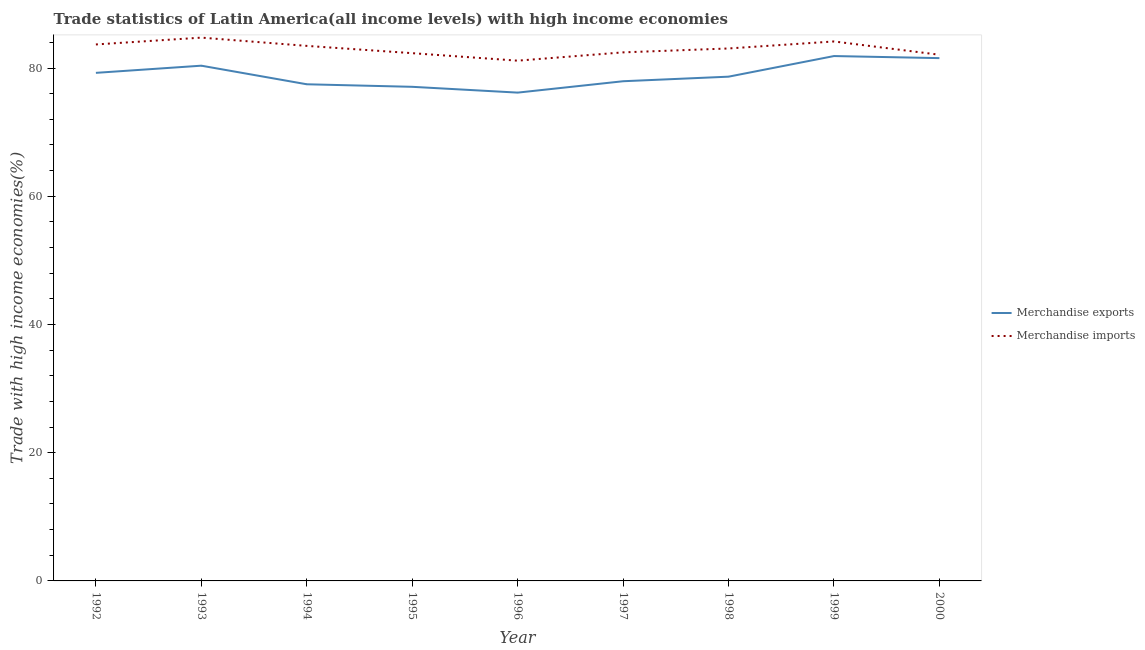Is the number of lines equal to the number of legend labels?
Ensure brevity in your answer.  Yes. What is the merchandise exports in 1997?
Give a very brief answer. 77.94. Across all years, what is the maximum merchandise imports?
Offer a terse response. 84.74. Across all years, what is the minimum merchandise imports?
Provide a short and direct response. 81.15. In which year was the merchandise exports minimum?
Ensure brevity in your answer.  1996. What is the total merchandise imports in the graph?
Provide a succinct answer. 747.07. What is the difference between the merchandise exports in 1992 and that in 2000?
Give a very brief answer. -2.3. What is the difference between the merchandise imports in 1997 and the merchandise exports in 2000?
Your response must be concise. 0.9. What is the average merchandise exports per year?
Your response must be concise. 78.93. In the year 1996, what is the difference between the merchandise imports and merchandise exports?
Your answer should be compact. 4.98. In how many years, is the merchandise imports greater than 28 %?
Provide a short and direct response. 9. What is the ratio of the merchandise exports in 1994 to that in 1998?
Offer a terse response. 0.98. What is the difference between the highest and the second highest merchandise imports?
Give a very brief answer. 0.6. What is the difference between the highest and the lowest merchandise exports?
Offer a terse response. 5.7. In how many years, is the merchandise exports greater than the average merchandise exports taken over all years?
Keep it short and to the point. 4. Is the sum of the merchandise imports in 1994 and 1995 greater than the maximum merchandise exports across all years?
Make the answer very short. Yes. Is the merchandise exports strictly greater than the merchandise imports over the years?
Your response must be concise. No. Is the merchandise imports strictly less than the merchandise exports over the years?
Offer a terse response. No. How many years are there in the graph?
Your answer should be compact. 9. What is the difference between two consecutive major ticks on the Y-axis?
Your answer should be compact. 20. Are the values on the major ticks of Y-axis written in scientific E-notation?
Provide a succinct answer. No. Does the graph contain any zero values?
Your answer should be compact. No. Where does the legend appear in the graph?
Provide a succinct answer. Center right. How many legend labels are there?
Provide a succinct answer. 2. How are the legend labels stacked?
Provide a succinct answer. Vertical. What is the title of the graph?
Provide a succinct answer. Trade statistics of Latin America(all income levels) with high income economies. Does "Not attending school" appear as one of the legend labels in the graph?
Your answer should be very brief. No. What is the label or title of the Y-axis?
Provide a short and direct response. Trade with high income economies(%). What is the Trade with high income economies(%) in Merchandise exports in 1992?
Make the answer very short. 79.25. What is the Trade with high income economies(%) in Merchandise imports in 1992?
Make the answer very short. 83.68. What is the Trade with high income economies(%) in Merchandise exports in 1993?
Keep it short and to the point. 80.37. What is the Trade with high income economies(%) of Merchandise imports in 1993?
Ensure brevity in your answer.  84.74. What is the Trade with high income economies(%) of Merchandise exports in 1994?
Provide a succinct answer. 77.47. What is the Trade with high income economies(%) in Merchandise imports in 1994?
Provide a succinct answer. 83.46. What is the Trade with high income economies(%) of Merchandise exports in 1995?
Your answer should be compact. 77.07. What is the Trade with high income economies(%) in Merchandise imports in 1995?
Provide a succinct answer. 82.32. What is the Trade with high income economies(%) of Merchandise exports in 1996?
Offer a terse response. 76.17. What is the Trade with high income economies(%) of Merchandise imports in 1996?
Provide a succinct answer. 81.15. What is the Trade with high income economies(%) in Merchandise exports in 1997?
Give a very brief answer. 77.94. What is the Trade with high income economies(%) in Merchandise imports in 1997?
Give a very brief answer. 82.45. What is the Trade with high income economies(%) of Merchandise exports in 1998?
Keep it short and to the point. 78.65. What is the Trade with high income economies(%) of Merchandise imports in 1998?
Your answer should be very brief. 83.05. What is the Trade with high income economies(%) of Merchandise exports in 1999?
Your response must be concise. 81.87. What is the Trade with high income economies(%) in Merchandise imports in 1999?
Your response must be concise. 84.15. What is the Trade with high income economies(%) in Merchandise exports in 2000?
Your response must be concise. 81.55. What is the Trade with high income economies(%) in Merchandise imports in 2000?
Ensure brevity in your answer.  82.07. Across all years, what is the maximum Trade with high income economies(%) in Merchandise exports?
Offer a very short reply. 81.87. Across all years, what is the maximum Trade with high income economies(%) in Merchandise imports?
Keep it short and to the point. 84.74. Across all years, what is the minimum Trade with high income economies(%) in Merchandise exports?
Make the answer very short. 76.17. Across all years, what is the minimum Trade with high income economies(%) in Merchandise imports?
Your answer should be compact. 81.15. What is the total Trade with high income economies(%) of Merchandise exports in the graph?
Your response must be concise. 710.34. What is the total Trade with high income economies(%) in Merchandise imports in the graph?
Give a very brief answer. 747.07. What is the difference between the Trade with high income economies(%) in Merchandise exports in 1992 and that in 1993?
Your answer should be very brief. -1.12. What is the difference between the Trade with high income economies(%) in Merchandise imports in 1992 and that in 1993?
Give a very brief answer. -1.06. What is the difference between the Trade with high income economies(%) of Merchandise exports in 1992 and that in 1994?
Make the answer very short. 1.78. What is the difference between the Trade with high income economies(%) of Merchandise imports in 1992 and that in 1994?
Ensure brevity in your answer.  0.22. What is the difference between the Trade with high income economies(%) of Merchandise exports in 1992 and that in 1995?
Keep it short and to the point. 2.18. What is the difference between the Trade with high income economies(%) of Merchandise imports in 1992 and that in 1995?
Offer a terse response. 1.36. What is the difference between the Trade with high income economies(%) in Merchandise exports in 1992 and that in 1996?
Your answer should be compact. 3.08. What is the difference between the Trade with high income economies(%) in Merchandise imports in 1992 and that in 1996?
Keep it short and to the point. 2.53. What is the difference between the Trade with high income economies(%) of Merchandise exports in 1992 and that in 1997?
Make the answer very short. 1.31. What is the difference between the Trade with high income economies(%) of Merchandise imports in 1992 and that in 1997?
Ensure brevity in your answer.  1.23. What is the difference between the Trade with high income economies(%) of Merchandise exports in 1992 and that in 1998?
Your answer should be very brief. 0.6. What is the difference between the Trade with high income economies(%) in Merchandise imports in 1992 and that in 1998?
Your response must be concise. 0.63. What is the difference between the Trade with high income economies(%) in Merchandise exports in 1992 and that in 1999?
Give a very brief answer. -2.62. What is the difference between the Trade with high income economies(%) of Merchandise imports in 1992 and that in 1999?
Your answer should be compact. -0.47. What is the difference between the Trade with high income economies(%) in Merchandise exports in 1992 and that in 2000?
Provide a succinct answer. -2.3. What is the difference between the Trade with high income economies(%) of Merchandise imports in 1992 and that in 2000?
Keep it short and to the point. 1.61. What is the difference between the Trade with high income economies(%) in Merchandise exports in 1993 and that in 1994?
Make the answer very short. 2.9. What is the difference between the Trade with high income economies(%) in Merchandise imports in 1993 and that in 1994?
Make the answer very short. 1.29. What is the difference between the Trade with high income economies(%) in Merchandise exports in 1993 and that in 1995?
Make the answer very short. 3.29. What is the difference between the Trade with high income economies(%) in Merchandise imports in 1993 and that in 1995?
Provide a short and direct response. 2.42. What is the difference between the Trade with high income economies(%) of Merchandise exports in 1993 and that in 1996?
Offer a very short reply. 4.2. What is the difference between the Trade with high income economies(%) in Merchandise imports in 1993 and that in 1996?
Your answer should be very brief. 3.59. What is the difference between the Trade with high income economies(%) of Merchandise exports in 1993 and that in 1997?
Provide a short and direct response. 2.43. What is the difference between the Trade with high income economies(%) of Merchandise imports in 1993 and that in 1997?
Give a very brief answer. 2.3. What is the difference between the Trade with high income economies(%) of Merchandise exports in 1993 and that in 1998?
Provide a succinct answer. 1.71. What is the difference between the Trade with high income economies(%) of Merchandise imports in 1993 and that in 1998?
Keep it short and to the point. 1.69. What is the difference between the Trade with high income economies(%) in Merchandise exports in 1993 and that in 1999?
Keep it short and to the point. -1.5. What is the difference between the Trade with high income economies(%) of Merchandise imports in 1993 and that in 1999?
Offer a very short reply. 0.6. What is the difference between the Trade with high income economies(%) of Merchandise exports in 1993 and that in 2000?
Your answer should be compact. -1.18. What is the difference between the Trade with high income economies(%) in Merchandise imports in 1993 and that in 2000?
Provide a short and direct response. 2.67. What is the difference between the Trade with high income economies(%) of Merchandise exports in 1994 and that in 1995?
Provide a succinct answer. 0.4. What is the difference between the Trade with high income economies(%) in Merchandise imports in 1994 and that in 1995?
Offer a very short reply. 1.14. What is the difference between the Trade with high income economies(%) in Merchandise exports in 1994 and that in 1996?
Keep it short and to the point. 1.3. What is the difference between the Trade with high income economies(%) of Merchandise imports in 1994 and that in 1996?
Offer a very short reply. 2.31. What is the difference between the Trade with high income economies(%) in Merchandise exports in 1994 and that in 1997?
Provide a succinct answer. -0.47. What is the difference between the Trade with high income economies(%) of Merchandise imports in 1994 and that in 1997?
Your answer should be compact. 1.01. What is the difference between the Trade with high income economies(%) of Merchandise exports in 1994 and that in 1998?
Provide a succinct answer. -1.19. What is the difference between the Trade with high income economies(%) in Merchandise imports in 1994 and that in 1998?
Your answer should be very brief. 0.4. What is the difference between the Trade with high income economies(%) of Merchandise exports in 1994 and that in 1999?
Offer a terse response. -4.4. What is the difference between the Trade with high income economies(%) in Merchandise imports in 1994 and that in 1999?
Offer a very short reply. -0.69. What is the difference between the Trade with high income economies(%) of Merchandise exports in 1994 and that in 2000?
Your answer should be compact. -4.08. What is the difference between the Trade with high income economies(%) of Merchandise imports in 1994 and that in 2000?
Make the answer very short. 1.38. What is the difference between the Trade with high income economies(%) in Merchandise exports in 1995 and that in 1996?
Make the answer very short. 0.91. What is the difference between the Trade with high income economies(%) of Merchandise imports in 1995 and that in 1996?
Ensure brevity in your answer.  1.17. What is the difference between the Trade with high income economies(%) in Merchandise exports in 1995 and that in 1997?
Provide a succinct answer. -0.87. What is the difference between the Trade with high income economies(%) in Merchandise imports in 1995 and that in 1997?
Offer a very short reply. -0.13. What is the difference between the Trade with high income economies(%) in Merchandise exports in 1995 and that in 1998?
Your answer should be compact. -1.58. What is the difference between the Trade with high income economies(%) in Merchandise imports in 1995 and that in 1998?
Offer a terse response. -0.73. What is the difference between the Trade with high income economies(%) of Merchandise exports in 1995 and that in 1999?
Keep it short and to the point. -4.8. What is the difference between the Trade with high income economies(%) of Merchandise imports in 1995 and that in 1999?
Your answer should be compact. -1.83. What is the difference between the Trade with high income economies(%) of Merchandise exports in 1995 and that in 2000?
Your response must be concise. -4.48. What is the difference between the Trade with high income economies(%) of Merchandise imports in 1995 and that in 2000?
Your response must be concise. 0.25. What is the difference between the Trade with high income economies(%) in Merchandise exports in 1996 and that in 1997?
Keep it short and to the point. -1.77. What is the difference between the Trade with high income economies(%) of Merchandise imports in 1996 and that in 1997?
Your answer should be very brief. -1.3. What is the difference between the Trade with high income economies(%) in Merchandise exports in 1996 and that in 1998?
Ensure brevity in your answer.  -2.49. What is the difference between the Trade with high income economies(%) in Merchandise imports in 1996 and that in 1998?
Make the answer very short. -1.9. What is the difference between the Trade with high income economies(%) in Merchandise exports in 1996 and that in 1999?
Provide a succinct answer. -5.7. What is the difference between the Trade with high income economies(%) in Merchandise imports in 1996 and that in 1999?
Your answer should be very brief. -3. What is the difference between the Trade with high income economies(%) of Merchandise exports in 1996 and that in 2000?
Ensure brevity in your answer.  -5.38. What is the difference between the Trade with high income economies(%) in Merchandise imports in 1996 and that in 2000?
Offer a very short reply. -0.92. What is the difference between the Trade with high income economies(%) in Merchandise exports in 1997 and that in 1998?
Provide a succinct answer. -0.71. What is the difference between the Trade with high income economies(%) in Merchandise imports in 1997 and that in 1998?
Keep it short and to the point. -0.61. What is the difference between the Trade with high income economies(%) in Merchandise exports in 1997 and that in 1999?
Provide a short and direct response. -3.93. What is the difference between the Trade with high income economies(%) in Merchandise imports in 1997 and that in 1999?
Give a very brief answer. -1.7. What is the difference between the Trade with high income economies(%) in Merchandise exports in 1997 and that in 2000?
Provide a short and direct response. -3.61. What is the difference between the Trade with high income economies(%) of Merchandise imports in 1997 and that in 2000?
Make the answer very short. 0.37. What is the difference between the Trade with high income economies(%) of Merchandise exports in 1998 and that in 1999?
Offer a terse response. -3.22. What is the difference between the Trade with high income economies(%) of Merchandise imports in 1998 and that in 1999?
Your answer should be compact. -1.09. What is the difference between the Trade with high income economies(%) of Merchandise exports in 1998 and that in 2000?
Provide a succinct answer. -2.89. What is the difference between the Trade with high income economies(%) in Merchandise imports in 1998 and that in 2000?
Make the answer very short. 0.98. What is the difference between the Trade with high income economies(%) of Merchandise exports in 1999 and that in 2000?
Provide a succinct answer. 0.32. What is the difference between the Trade with high income economies(%) in Merchandise imports in 1999 and that in 2000?
Keep it short and to the point. 2.07. What is the difference between the Trade with high income economies(%) in Merchandise exports in 1992 and the Trade with high income economies(%) in Merchandise imports in 1993?
Your answer should be compact. -5.49. What is the difference between the Trade with high income economies(%) in Merchandise exports in 1992 and the Trade with high income economies(%) in Merchandise imports in 1994?
Give a very brief answer. -4.21. What is the difference between the Trade with high income economies(%) of Merchandise exports in 1992 and the Trade with high income economies(%) of Merchandise imports in 1995?
Offer a terse response. -3.07. What is the difference between the Trade with high income economies(%) in Merchandise exports in 1992 and the Trade with high income economies(%) in Merchandise imports in 1996?
Your answer should be very brief. -1.9. What is the difference between the Trade with high income economies(%) of Merchandise exports in 1992 and the Trade with high income economies(%) of Merchandise imports in 1997?
Offer a terse response. -3.2. What is the difference between the Trade with high income economies(%) of Merchandise exports in 1992 and the Trade with high income economies(%) of Merchandise imports in 1998?
Give a very brief answer. -3.8. What is the difference between the Trade with high income economies(%) in Merchandise exports in 1992 and the Trade with high income economies(%) in Merchandise imports in 1999?
Make the answer very short. -4.9. What is the difference between the Trade with high income economies(%) of Merchandise exports in 1992 and the Trade with high income economies(%) of Merchandise imports in 2000?
Provide a succinct answer. -2.82. What is the difference between the Trade with high income economies(%) of Merchandise exports in 1993 and the Trade with high income economies(%) of Merchandise imports in 1994?
Provide a succinct answer. -3.09. What is the difference between the Trade with high income economies(%) of Merchandise exports in 1993 and the Trade with high income economies(%) of Merchandise imports in 1995?
Offer a terse response. -1.95. What is the difference between the Trade with high income economies(%) in Merchandise exports in 1993 and the Trade with high income economies(%) in Merchandise imports in 1996?
Your answer should be very brief. -0.78. What is the difference between the Trade with high income economies(%) of Merchandise exports in 1993 and the Trade with high income economies(%) of Merchandise imports in 1997?
Give a very brief answer. -2.08. What is the difference between the Trade with high income economies(%) of Merchandise exports in 1993 and the Trade with high income economies(%) of Merchandise imports in 1998?
Ensure brevity in your answer.  -2.69. What is the difference between the Trade with high income economies(%) in Merchandise exports in 1993 and the Trade with high income economies(%) in Merchandise imports in 1999?
Your answer should be very brief. -3.78. What is the difference between the Trade with high income economies(%) in Merchandise exports in 1993 and the Trade with high income economies(%) in Merchandise imports in 2000?
Your answer should be compact. -1.71. What is the difference between the Trade with high income economies(%) in Merchandise exports in 1994 and the Trade with high income economies(%) in Merchandise imports in 1995?
Make the answer very short. -4.85. What is the difference between the Trade with high income economies(%) of Merchandise exports in 1994 and the Trade with high income economies(%) of Merchandise imports in 1996?
Keep it short and to the point. -3.68. What is the difference between the Trade with high income economies(%) in Merchandise exports in 1994 and the Trade with high income economies(%) in Merchandise imports in 1997?
Provide a succinct answer. -4.98. What is the difference between the Trade with high income economies(%) of Merchandise exports in 1994 and the Trade with high income economies(%) of Merchandise imports in 1998?
Give a very brief answer. -5.59. What is the difference between the Trade with high income economies(%) in Merchandise exports in 1994 and the Trade with high income economies(%) in Merchandise imports in 1999?
Your answer should be very brief. -6.68. What is the difference between the Trade with high income economies(%) in Merchandise exports in 1994 and the Trade with high income economies(%) in Merchandise imports in 2000?
Offer a terse response. -4.61. What is the difference between the Trade with high income economies(%) of Merchandise exports in 1995 and the Trade with high income economies(%) of Merchandise imports in 1996?
Make the answer very short. -4.08. What is the difference between the Trade with high income economies(%) in Merchandise exports in 1995 and the Trade with high income economies(%) in Merchandise imports in 1997?
Provide a succinct answer. -5.37. What is the difference between the Trade with high income economies(%) of Merchandise exports in 1995 and the Trade with high income economies(%) of Merchandise imports in 1998?
Make the answer very short. -5.98. What is the difference between the Trade with high income economies(%) of Merchandise exports in 1995 and the Trade with high income economies(%) of Merchandise imports in 1999?
Give a very brief answer. -7.08. What is the difference between the Trade with high income economies(%) in Merchandise exports in 1995 and the Trade with high income economies(%) in Merchandise imports in 2000?
Your response must be concise. -5. What is the difference between the Trade with high income economies(%) of Merchandise exports in 1996 and the Trade with high income economies(%) of Merchandise imports in 1997?
Offer a terse response. -6.28. What is the difference between the Trade with high income economies(%) of Merchandise exports in 1996 and the Trade with high income economies(%) of Merchandise imports in 1998?
Offer a very short reply. -6.89. What is the difference between the Trade with high income economies(%) in Merchandise exports in 1996 and the Trade with high income economies(%) in Merchandise imports in 1999?
Provide a succinct answer. -7.98. What is the difference between the Trade with high income economies(%) of Merchandise exports in 1996 and the Trade with high income economies(%) of Merchandise imports in 2000?
Keep it short and to the point. -5.91. What is the difference between the Trade with high income economies(%) of Merchandise exports in 1997 and the Trade with high income economies(%) of Merchandise imports in 1998?
Your answer should be very brief. -5.11. What is the difference between the Trade with high income economies(%) in Merchandise exports in 1997 and the Trade with high income economies(%) in Merchandise imports in 1999?
Provide a short and direct response. -6.21. What is the difference between the Trade with high income economies(%) in Merchandise exports in 1997 and the Trade with high income economies(%) in Merchandise imports in 2000?
Your answer should be compact. -4.13. What is the difference between the Trade with high income economies(%) in Merchandise exports in 1998 and the Trade with high income economies(%) in Merchandise imports in 1999?
Provide a short and direct response. -5.49. What is the difference between the Trade with high income economies(%) of Merchandise exports in 1998 and the Trade with high income economies(%) of Merchandise imports in 2000?
Provide a short and direct response. -3.42. What is the difference between the Trade with high income economies(%) in Merchandise exports in 1999 and the Trade with high income economies(%) in Merchandise imports in 2000?
Offer a terse response. -0.2. What is the average Trade with high income economies(%) in Merchandise exports per year?
Make the answer very short. 78.93. What is the average Trade with high income economies(%) of Merchandise imports per year?
Offer a terse response. 83.01. In the year 1992, what is the difference between the Trade with high income economies(%) of Merchandise exports and Trade with high income economies(%) of Merchandise imports?
Make the answer very short. -4.43. In the year 1993, what is the difference between the Trade with high income economies(%) of Merchandise exports and Trade with high income economies(%) of Merchandise imports?
Your answer should be very brief. -4.38. In the year 1994, what is the difference between the Trade with high income economies(%) in Merchandise exports and Trade with high income economies(%) in Merchandise imports?
Provide a short and direct response. -5.99. In the year 1995, what is the difference between the Trade with high income economies(%) of Merchandise exports and Trade with high income economies(%) of Merchandise imports?
Offer a terse response. -5.25. In the year 1996, what is the difference between the Trade with high income economies(%) of Merchandise exports and Trade with high income economies(%) of Merchandise imports?
Your response must be concise. -4.98. In the year 1997, what is the difference between the Trade with high income economies(%) of Merchandise exports and Trade with high income economies(%) of Merchandise imports?
Your answer should be compact. -4.5. In the year 1998, what is the difference between the Trade with high income economies(%) of Merchandise exports and Trade with high income economies(%) of Merchandise imports?
Your answer should be compact. -4.4. In the year 1999, what is the difference between the Trade with high income economies(%) of Merchandise exports and Trade with high income economies(%) of Merchandise imports?
Keep it short and to the point. -2.28. In the year 2000, what is the difference between the Trade with high income economies(%) in Merchandise exports and Trade with high income economies(%) in Merchandise imports?
Your response must be concise. -0.53. What is the ratio of the Trade with high income economies(%) of Merchandise exports in 1992 to that in 1993?
Your answer should be compact. 0.99. What is the ratio of the Trade with high income economies(%) of Merchandise imports in 1992 to that in 1993?
Your response must be concise. 0.99. What is the ratio of the Trade with high income economies(%) in Merchandise exports in 1992 to that in 1994?
Provide a short and direct response. 1.02. What is the ratio of the Trade with high income economies(%) of Merchandise imports in 1992 to that in 1994?
Provide a short and direct response. 1. What is the ratio of the Trade with high income economies(%) of Merchandise exports in 1992 to that in 1995?
Provide a succinct answer. 1.03. What is the ratio of the Trade with high income economies(%) of Merchandise imports in 1992 to that in 1995?
Your answer should be compact. 1.02. What is the ratio of the Trade with high income economies(%) in Merchandise exports in 1992 to that in 1996?
Offer a very short reply. 1.04. What is the ratio of the Trade with high income economies(%) in Merchandise imports in 1992 to that in 1996?
Provide a succinct answer. 1.03. What is the ratio of the Trade with high income economies(%) in Merchandise exports in 1992 to that in 1997?
Keep it short and to the point. 1.02. What is the ratio of the Trade with high income economies(%) of Merchandise exports in 1992 to that in 1998?
Ensure brevity in your answer.  1.01. What is the ratio of the Trade with high income economies(%) of Merchandise imports in 1992 to that in 1998?
Offer a very short reply. 1.01. What is the ratio of the Trade with high income economies(%) of Merchandise exports in 1992 to that in 2000?
Ensure brevity in your answer.  0.97. What is the ratio of the Trade with high income economies(%) of Merchandise imports in 1992 to that in 2000?
Provide a succinct answer. 1.02. What is the ratio of the Trade with high income economies(%) of Merchandise exports in 1993 to that in 1994?
Give a very brief answer. 1.04. What is the ratio of the Trade with high income economies(%) of Merchandise imports in 1993 to that in 1994?
Provide a short and direct response. 1.02. What is the ratio of the Trade with high income economies(%) of Merchandise exports in 1993 to that in 1995?
Offer a terse response. 1.04. What is the ratio of the Trade with high income economies(%) in Merchandise imports in 1993 to that in 1995?
Ensure brevity in your answer.  1.03. What is the ratio of the Trade with high income economies(%) in Merchandise exports in 1993 to that in 1996?
Give a very brief answer. 1.06. What is the ratio of the Trade with high income economies(%) in Merchandise imports in 1993 to that in 1996?
Your answer should be compact. 1.04. What is the ratio of the Trade with high income economies(%) of Merchandise exports in 1993 to that in 1997?
Your answer should be very brief. 1.03. What is the ratio of the Trade with high income economies(%) in Merchandise imports in 1993 to that in 1997?
Give a very brief answer. 1.03. What is the ratio of the Trade with high income economies(%) in Merchandise exports in 1993 to that in 1998?
Offer a terse response. 1.02. What is the ratio of the Trade with high income economies(%) of Merchandise imports in 1993 to that in 1998?
Offer a terse response. 1.02. What is the ratio of the Trade with high income economies(%) in Merchandise exports in 1993 to that in 1999?
Provide a short and direct response. 0.98. What is the ratio of the Trade with high income economies(%) in Merchandise imports in 1993 to that in 1999?
Provide a succinct answer. 1.01. What is the ratio of the Trade with high income economies(%) in Merchandise exports in 1993 to that in 2000?
Provide a succinct answer. 0.99. What is the ratio of the Trade with high income economies(%) in Merchandise imports in 1993 to that in 2000?
Give a very brief answer. 1.03. What is the ratio of the Trade with high income economies(%) of Merchandise imports in 1994 to that in 1995?
Offer a terse response. 1.01. What is the ratio of the Trade with high income economies(%) in Merchandise exports in 1994 to that in 1996?
Give a very brief answer. 1.02. What is the ratio of the Trade with high income economies(%) of Merchandise imports in 1994 to that in 1996?
Provide a short and direct response. 1.03. What is the ratio of the Trade with high income economies(%) in Merchandise imports in 1994 to that in 1997?
Give a very brief answer. 1.01. What is the ratio of the Trade with high income economies(%) in Merchandise exports in 1994 to that in 1998?
Make the answer very short. 0.98. What is the ratio of the Trade with high income economies(%) in Merchandise exports in 1994 to that in 1999?
Your answer should be compact. 0.95. What is the ratio of the Trade with high income economies(%) in Merchandise imports in 1994 to that in 1999?
Make the answer very short. 0.99. What is the ratio of the Trade with high income economies(%) in Merchandise imports in 1994 to that in 2000?
Offer a very short reply. 1.02. What is the ratio of the Trade with high income economies(%) of Merchandise exports in 1995 to that in 1996?
Your response must be concise. 1.01. What is the ratio of the Trade with high income economies(%) in Merchandise imports in 1995 to that in 1996?
Ensure brevity in your answer.  1.01. What is the ratio of the Trade with high income economies(%) in Merchandise exports in 1995 to that in 1997?
Offer a terse response. 0.99. What is the ratio of the Trade with high income economies(%) in Merchandise imports in 1995 to that in 1997?
Provide a short and direct response. 1. What is the ratio of the Trade with high income economies(%) in Merchandise exports in 1995 to that in 1998?
Your answer should be very brief. 0.98. What is the ratio of the Trade with high income economies(%) of Merchandise imports in 1995 to that in 1998?
Ensure brevity in your answer.  0.99. What is the ratio of the Trade with high income economies(%) of Merchandise exports in 1995 to that in 1999?
Provide a succinct answer. 0.94. What is the ratio of the Trade with high income economies(%) in Merchandise imports in 1995 to that in 1999?
Keep it short and to the point. 0.98. What is the ratio of the Trade with high income economies(%) in Merchandise exports in 1995 to that in 2000?
Make the answer very short. 0.95. What is the ratio of the Trade with high income economies(%) of Merchandise imports in 1995 to that in 2000?
Ensure brevity in your answer.  1. What is the ratio of the Trade with high income economies(%) of Merchandise exports in 1996 to that in 1997?
Your response must be concise. 0.98. What is the ratio of the Trade with high income economies(%) of Merchandise imports in 1996 to that in 1997?
Provide a succinct answer. 0.98. What is the ratio of the Trade with high income economies(%) of Merchandise exports in 1996 to that in 1998?
Keep it short and to the point. 0.97. What is the ratio of the Trade with high income economies(%) of Merchandise imports in 1996 to that in 1998?
Provide a short and direct response. 0.98. What is the ratio of the Trade with high income economies(%) of Merchandise exports in 1996 to that in 1999?
Provide a succinct answer. 0.93. What is the ratio of the Trade with high income economies(%) in Merchandise imports in 1996 to that in 1999?
Ensure brevity in your answer.  0.96. What is the ratio of the Trade with high income economies(%) of Merchandise exports in 1996 to that in 2000?
Your answer should be compact. 0.93. What is the ratio of the Trade with high income economies(%) of Merchandise exports in 1997 to that in 1998?
Provide a succinct answer. 0.99. What is the ratio of the Trade with high income economies(%) of Merchandise imports in 1997 to that in 1998?
Make the answer very short. 0.99. What is the ratio of the Trade with high income economies(%) of Merchandise imports in 1997 to that in 1999?
Provide a succinct answer. 0.98. What is the ratio of the Trade with high income economies(%) in Merchandise exports in 1997 to that in 2000?
Your answer should be compact. 0.96. What is the ratio of the Trade with high income economies(%) of Merchandise imports in 1997 to that in 2000?
Offer a terse response. 1. What is the ratio of the Trade with high income economies(%) in Merchandise exports in 1998 to that in 1999?
Make the answer very short. 0.96. What is the ratio of the Trade with high income economies(%) in Merchandise imports in 1998 to that in 1999?
Your answer should be compact. 0.99. What is the ratio of the Trade with high income economies(%) of Merchandise exports in 1998 to that in 2000?
Ensure brevity in your answer.  0.96. What is the ratio of the Trade with high income economies(%) in Merchandise imports in 1998 to that in 2000?
Provide a succinct answer. 1.01. What is the ratio of the Trade with high income economies(%) of Merchandise imports in 1999 to that in 2000?
Offer a terse response. 1.03. What is the difference between the highest and the second highest Trade with high income economies(%) in Merchandise exports?
Your response must be concise. 0.32. What is the difference between the highest and the second highest Trade with high income economies(%) in Merchandise imports?
Your answer should be very brief. 0.6. What is the difference between the highest and the lowest Trade with high income economies(%) of Merchandise exports?
Provide a succinct answer. 5.7. What is the difference between the highest and the lowest Trade with high income economies(%) of Merchandise imports?
Give a very brief answer. 3.59. 